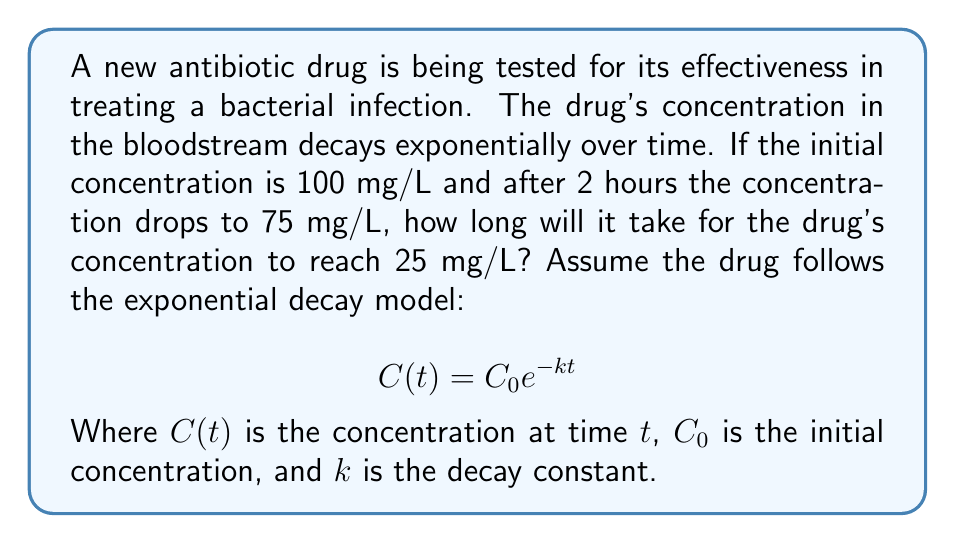Give your solution to this math problem. To solve this problem, we'll follow these steps:

1. Determine the decay constant $k$ using the given information.
2. Use the decay constant to find the time when the concentration reaches 25 mg/L.

Step 1: Finding the decay constant $k$

We know that:
$C_0 = 100$ mg/L
$C(2) = 75$ mg/L

Using the exponential decay model:
$$75 = 100 e^{-2k}$$

Dividing both sides by 100:
$$0.75 = e^{-2k}$$

Taking the natural logarithm of both sides:
$$\ln(0.75) = -2k$$

Solving for $k$:
$$k = -\frac{\ln(0.75)}{2} \approx 0.1438$$

Step 2: Finding the time when concentration reaches 25 mg/L

Now we use the decay constant to find the time $t$ when $C(t) = 25$ mg/L:

$$25 = 100 e^{-0.1438t}$$

Dividing both sides by 100:
$$0.25 = e^{-0.1438t}$$

Taking the natural logarithm of both sides:
$$\ln(0.25) = -0.1438t$$

Solving for $t$:
$$t = -\frac{\ln(0.25)}{0.1438} \approx 9.6268$$

Therefore, it will take approximately 9.63 hours for the drug's concentration to reach 25 mg/L.
Answer: 9.63 hours 